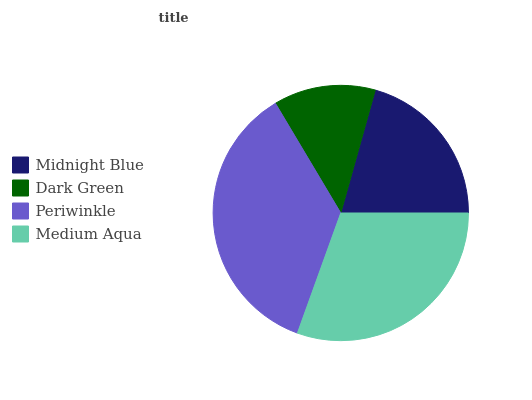Is Dark Green the minimum?
Answer yes or no. Yes. Is Periwinkle the maximum?
Answer yes or no. Yes. Is Periwinkle the minimum?
Answer yes or no. No. Is Dark Green the maximum?
Answer yes or no. No. Is Periwinkle greater than Dark Green?
Answer yes or no. Yes. Is Dark Green less than Periwinkle?
Answer yes or no. Yes. Is Dark Green greater than Periwinkle?
Answer yes or no. No. Is Periwinkle less than Dark Green?
Answer yes or no. No. Is Medium Aqua the high median?
Answer yes or no. Yes. Is Midnight Blue the low median?
Answer yes or no. Yes. Is Midnight Blue the high median?
Answer yes or no. No. Is Dark Green the low median?
Answer yes or no. No. 